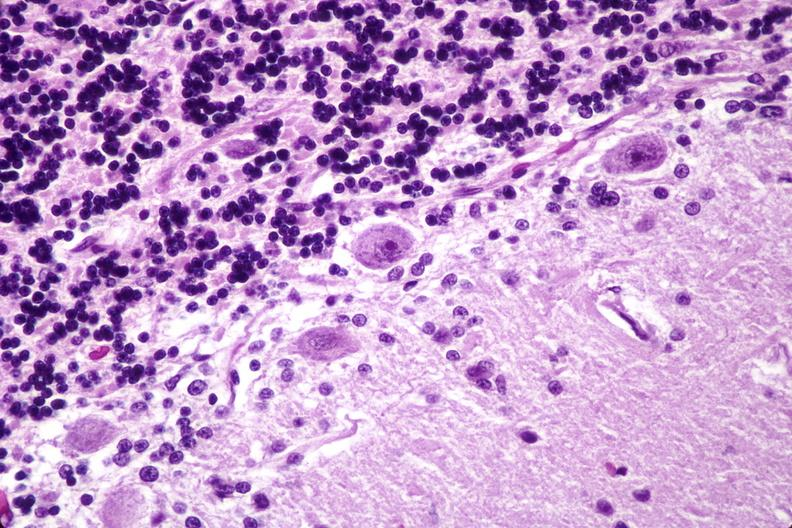where is this?
Answer the question using a single word or phrase. Nervous 